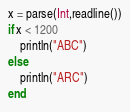Convert code to text. <code><loc_0><loc_0><loc_500><loc_500><_Julia_>x = parse(Int,readline())
if x < 1200
    println("ABC")
else
    println("ARC")
end</code> 